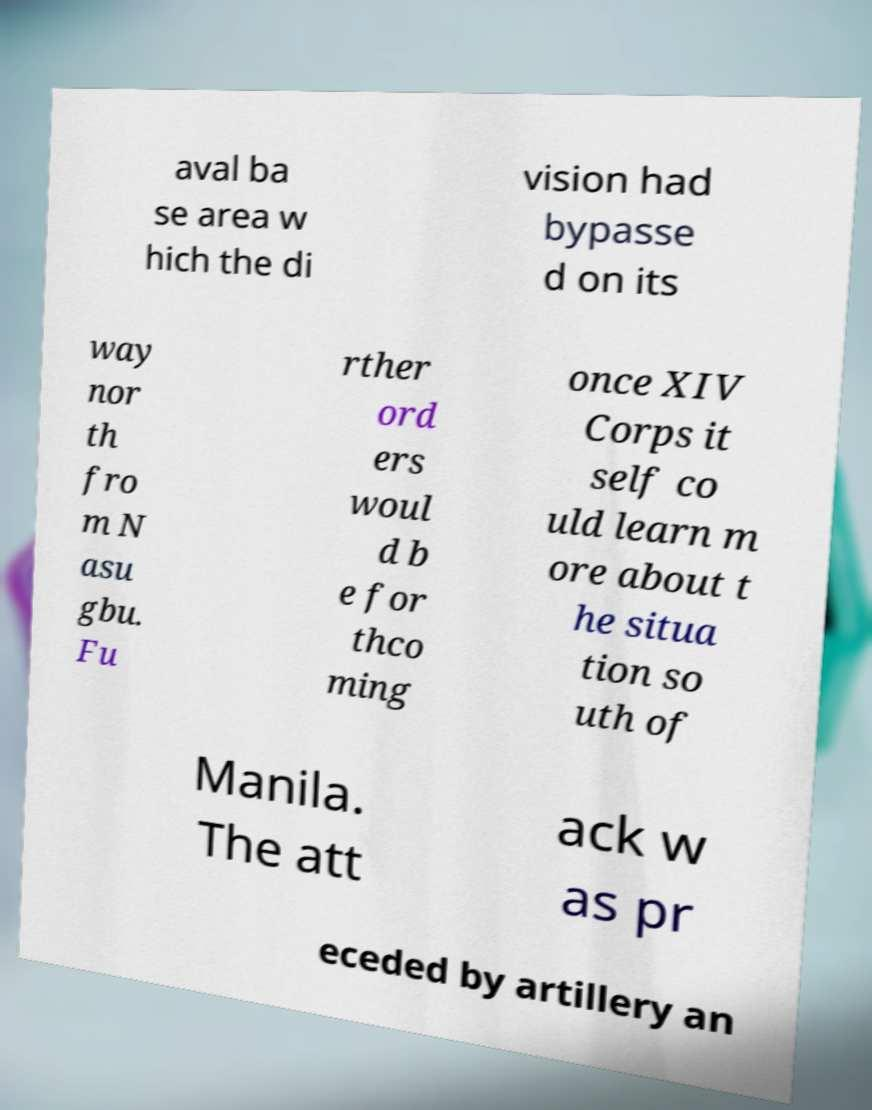Could you assist in decoding the text presented in this image and type it out clearly? aval ba se area w hich the di vision had bypasse d on its way nor th fro m N asu gbu. Fu rther ord ers woul d b e for thco ming once XIV Corps it self co uld learn m ore about t he situa tion so uth of Manila. The att ack w as pr eceded by artillery an 